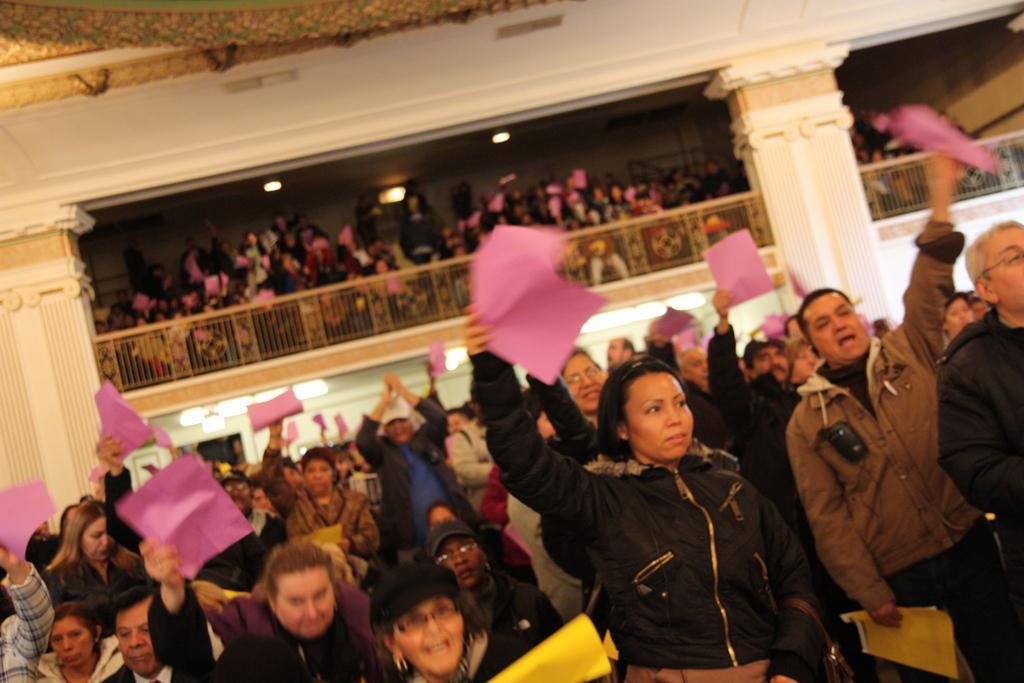How would you summarize this image in a sentence or two? In this picture I can see a group of people are holding the papers, in the background there is a railing, there are lot of people, at the top there are lights. 